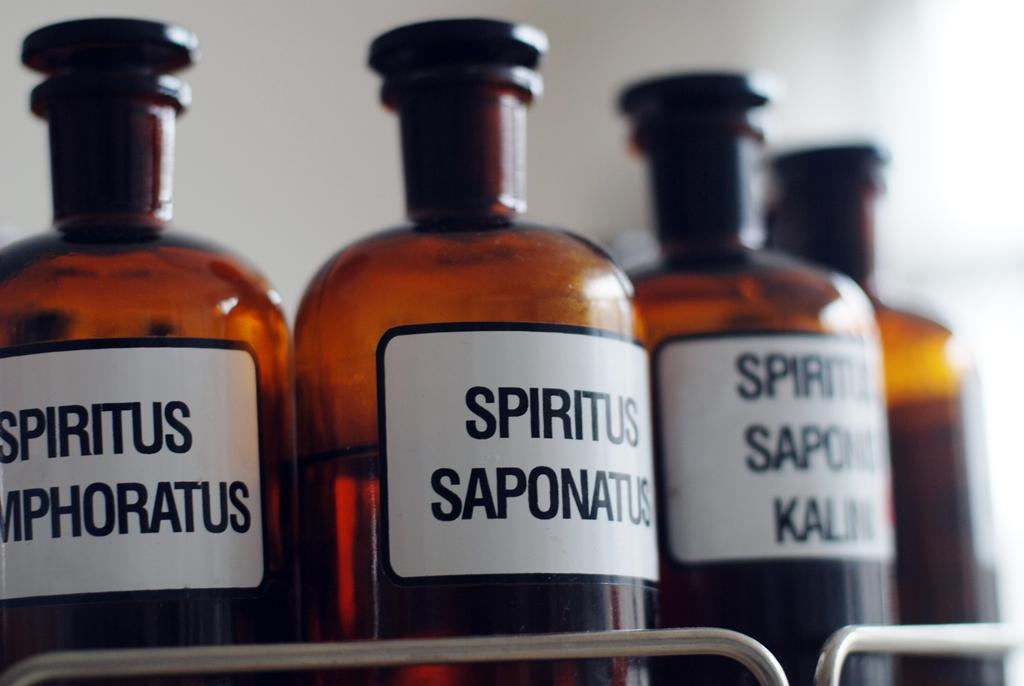<image>
Summarize the visual content of the image. Many bottles of Spiritus Saponatus are next to each other. 